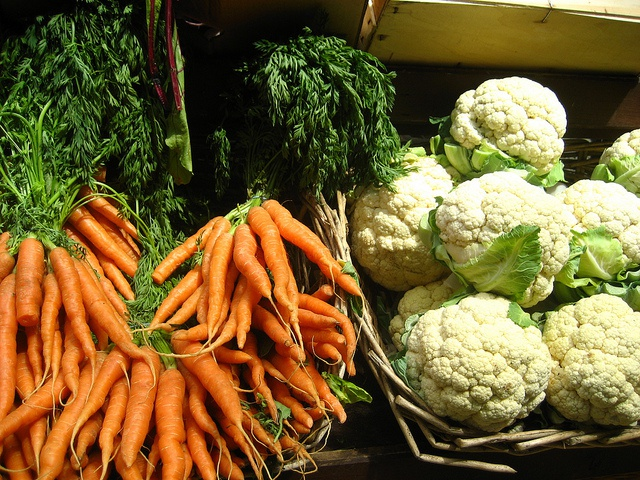Describe the objects in this image and their specific colors. I can see carrot in black, red, and maroon tones, carrot in black, orange, red, and maroon tones, carrot in black, orange, red, and brown tones, carrot in black, orange, and red tones, and carrot in black, red, orange, and brown tones in this image. 